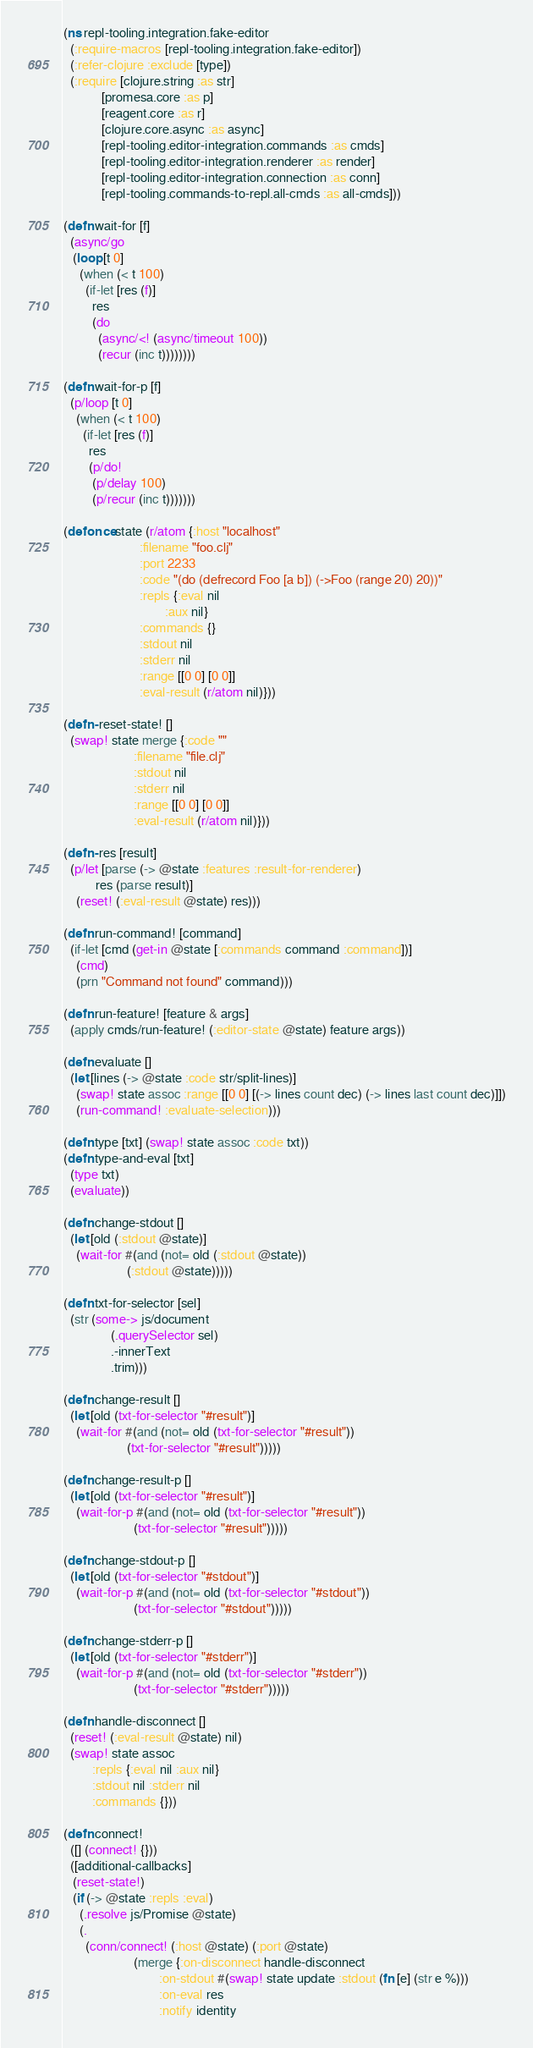<code> <loc_0><loc_0><loc_500><loc_500><_Clojure_>(ns repl-tooling.integration.fake-editor
  (:require-macros [repl-tooling.integration.fake-editor])
  (:refer-clojure :exclude [type])
  (:require [clojure.string :as str]
            [promesa.core :as p]
            [reagent.core :as r]
            [clojure.core.async :as async]
            [repl-tooling.editor-integration.commands :as cmds]
            [repl-tooling.editor-integration.renderer :as render]
            [repl-tooling.editor-integration.connection :as conn]
            [repl-tooling.commands-to-repl.all-cmds :as all-cmds]))

(defn wait-for [f]
  (async/go
   (loop [t 0]
     (when (< t 100)
       (if-let [res (f)]
         res
         (do
           (async/<! (async/timeout 100))
           (recur (inc t))))))))

(defn wait-for-p [f]
  (p/loop [t 0]
    (when (< t 100)
      (if-let [res (f)]
        res
        (p/do!
         (p/delay 100)
         (p/recur (inc t)))))))

(defonce state (r/atom {:host "localhost"
                        :filename "foo.clj"
                        :port 2233
                        :code "(do (defrecord Foo [a b]) (->Foo (range 20) 20))"
                        :repls {:eval nil
                                :aux nil}
                        :commands {}
                        :stdout nil
                        :stderr nil
                        :range [[0 0] [0 0]]
                        :eval-result (r/atom nil)}))

(defn- reset-state! []
  (swap! state merge {:code ""
                      :filename "file.clj"
                      :stdout nil
                      :stderr nil
                      :range [[0 0] [0 0]]
                      :eval-result (r/atom nil)}))

(defn- res [result]
  (p/let [parse (-> @state :features :result-for-renderer)
          res (parse result)]
    (reset! (:eval-result @state) res)))

(defn run-command! [command]
  (if-let [cmd (get-in @state [:commands command :command])]
    (cmd)
    (prn "Command not found" command)))

(defn run-feature! [feature & args]
  (apply cmds/run-feature! (:editor-state @state) feature args))

(defn evaluate []
  (let [lines (-> @state :code str/split-lines)]
    (swap! state assoc :range [[0 0] [(-> lines count dec) (-> lines last count dec)]])
    (run-command! :evaluate-selection)))

(defn type [txt] (swap! state assoc :code txt))
(defn type-and-eval [txt]
  (type txt)
  (evaluate))

(defn change-stdout []
  (let [old (:stdout @state)]
    (wait-for #(and (not= old (:stdout @state))
                    (:stdout @state)))))

(defn txt-for-selector [sel]
  (str (some-> js/document
               (.querySelector sel)
               .-innerText
               .trim)))

(defn change-result []
  (let [old (txt-for-selector "#result")]
    (wait-for #(and (not= old (txt-for-selector "#result"))
                    (txt-for-selector "#result")))))

(defn change-result-p []
  (let [old (txt-for-selector "#result")]
    (wait-for-p #(and (not= old (txt-for-selector "#result"))
                      (txt-for-selector "#result")))))

(defn change-stdout-p []
  (let [old (txt-for-selector "#stdout")]
    (wait-for-p #(and (not= old (txt-for-selector "#stdout"))
                      (txt-for-selector "#stdout")))))

(defn change-stderr-p []
  (let [old (txt-for-selector "#stderr")]
    (wait-for-p #(and (not= old (txt-for-selector "#stderr"))
                      (txt-for-selector "#stderr")))))

(defn handle-disconnect []
  (reset! (:eval-result @state) nil)
  (swap! state assoc
         :repls {:eval nil :aux nil}
         :stdout nil :stderr nil
         :commands {}))

(defn connect!
  ([] (connect! {}))
  ([additional-callbacks]
   (reset-state!)
   (if (-> @state :repls :eval)
     (.resolve js/Promise @state)
     (.
       (conn/connect! (:host @state) (:port @state)
                      (merge {:on-disconnect handle-disconnect
                              :on-stdout #(swap! state update :stdout (fn [e] (str e %)))
                              :on-eval res
                              :notify identity</code> 